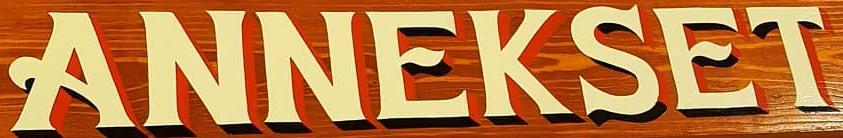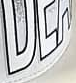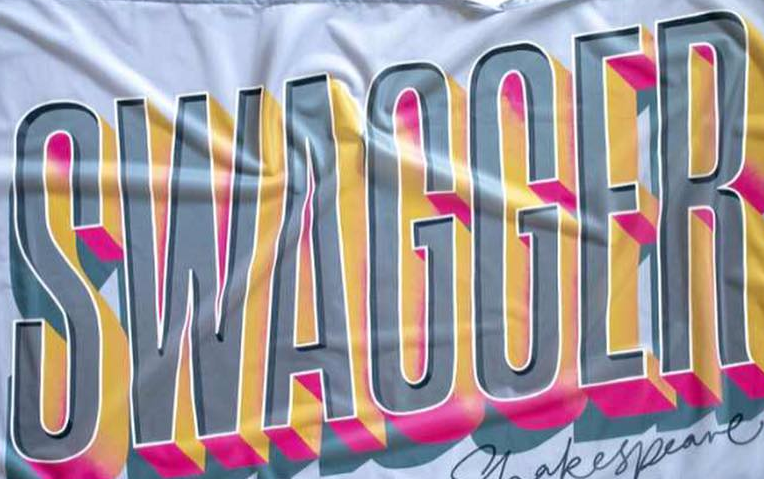Transcribe the words shown in these images in order, separated by a semicolon. ANNEKSET; ###; SWAGGER 